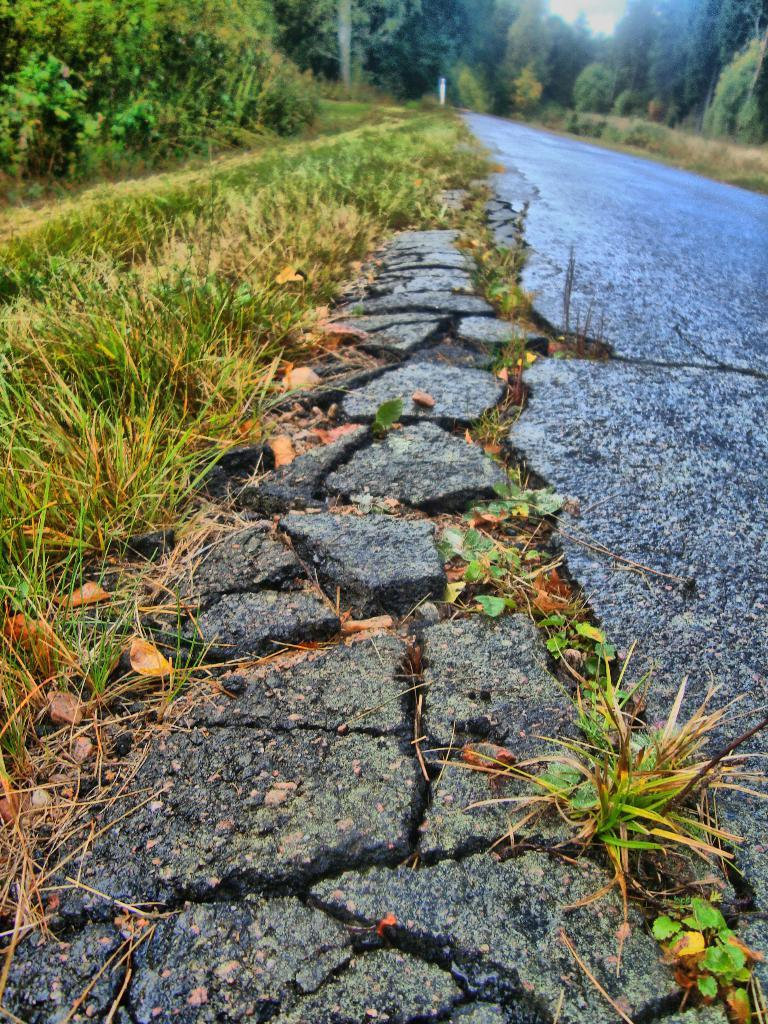What type of vegetation is present on the left side of the image? There is grass on the ground on the left side of the image. What can be seen in the top right of the image? There are trees on the top right of the image. What feature allows for movement through the area depicted in the image? There is a path visible in the image. Can you tell me how many goldfish are swimming in the pond in the image? There is no pond or goldfish present in the image; it features grass, trees, and a path. What type of club is being used by the person in the image? There is no person or club present in the image. 